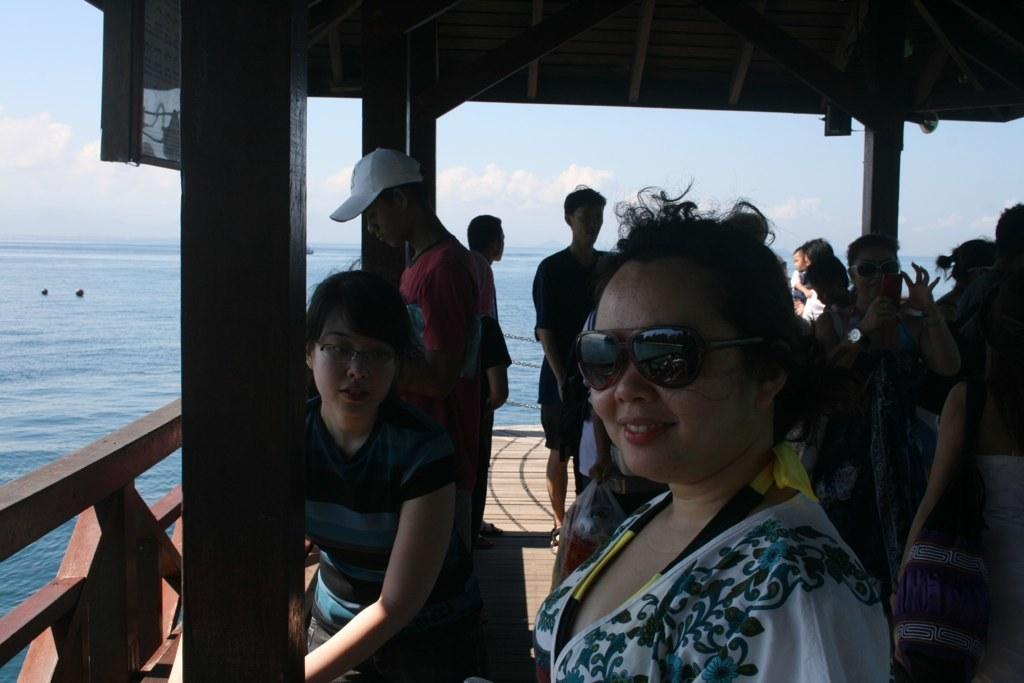What is the main subject of the image? There is a group of people in the image. What object can be seen in the image besides the people? There is a board in the image. What natural element is visible in the image? Water is visible in the image. What can be seen in the background of the image? The sky is visible in the background of the image, and there are clouds in the sky. What type of crayon is being used by the people in the image? There is no crayon present in the image; it features a group of people and a board, but no crayons. How much rice is visible in the image? There is: There is no rice present in the image. 